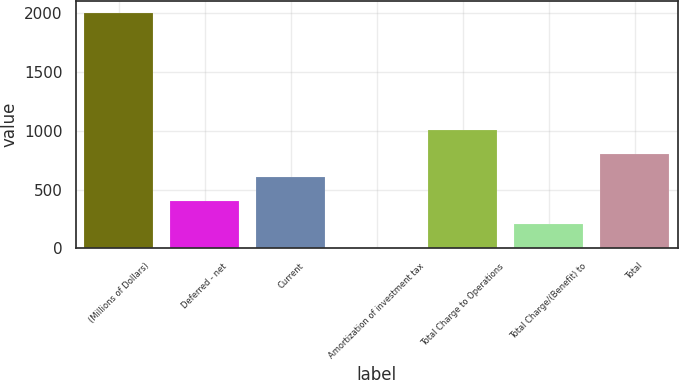Convert chart to OTSL. <chart><loc_0><loc_0><loc_500><loc_500><bar_chart><fcel>(Millions of Dollars)<fcel>Deferred - net<fcel>Current<fcel>Amortization of investment tax<fcel>Total Charge to Operations<fcel>Total Charge/(Benefit) to<fcel>Total<nl><fcel>2004<fcel>405.6<fcel>605.4<fcel>6<fcel>1005<fcel>205.8<fcel>805.2<nl></chart> 